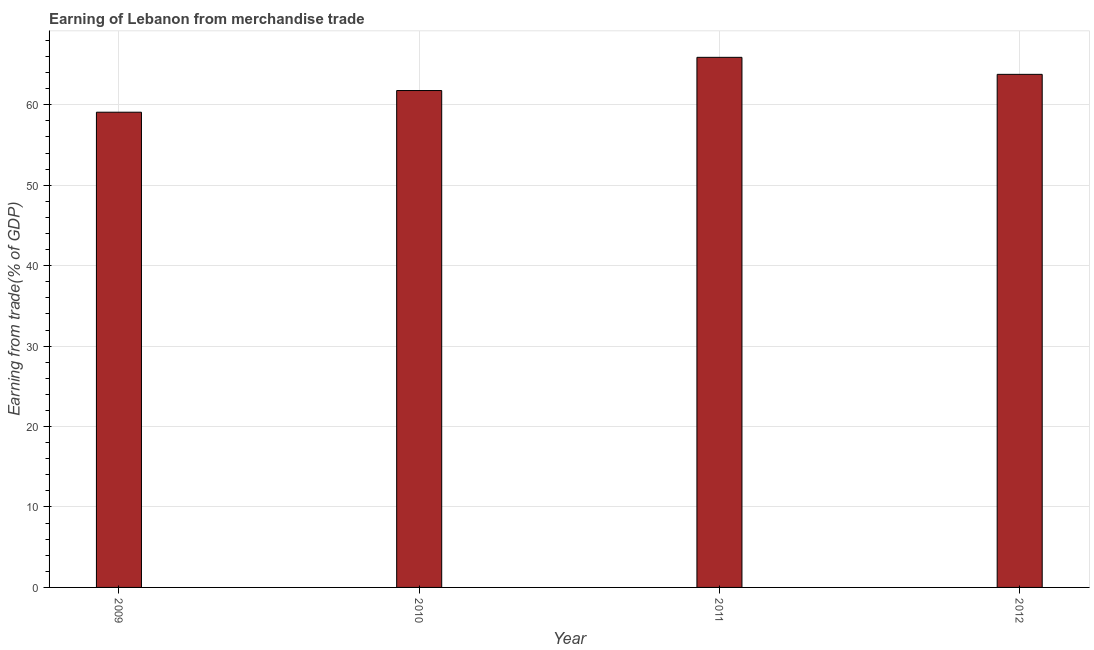Does the graph contain any zero values?
Give a very brief answer. No. What is the title of the graph?
Ensure brevity in your answer.  Earning of Lebanon from merchandise trade. What is the label or title of the Y-axis?
Provide a succinct answer. Earning from trade(% of GDP). What is the earning from merchandise trade in 2012?
Your answer should be compact. 63.79. Across all years, what is the maximum earning from merchandise trade?
Keep it short and to the point. 65.9. Across all years, what is the minimum earning from merchandise trade?
Provide a succinct answer. 59.08. In which year was the earning from merchandise trade maximum?
Your answer should be compact. 2011. What is the sum of the earning from merchandise trade?
Provide a short and direct response. 250.55. What is the difference between the earning from merchandise trade in 2009 and 2012?
Make the answer very short. -4.71. What is the average earning from merchandise trade per year?
Offer a terse response. 62.64. What is the median earning from merchandise trade?
Your answer should be very brief. 62.78. In how many years, is the earning from merchandise trade greater than 14 %?
Offer a very short reply. 4. What is the ratio of the earning from merchandise trade in 2009 to that in 2010?
Give a very brief answer. 0.96. Is the difference between the earning from merchandise trade in 2010 and 2012 greater than the difference between any two years?
Offer a very short reply. No. What is the difference between the highest and the second highest earning from merchandise trade?
Make the answer very short. 2.12. Is the sum of the earning from merchandise trade in 2010 and 2011 greater than the maximum earning from merchandise trade across all years?
Your response must be concise. Yes. What is the difference between the highest and the lowest earning from merchandise trade?
Your response must be concise. 6.82. In how many years, is the earning from merchandise trade greater than the average earning from merchandise trade taken over all years?
Provide a succinct answer. 2. How many bars are there?
Provide a succinct answer. 4. Are all the bars in the graph horizontal?
Make the answer very short. No. How many years are there in the graph?
Ensure brevity in your answer.  4. Are the values on the major ticks of Y-axis written in scientific E-notation?
Offer a terse response. No. What is the Earning from trade(% of GDP) in 2009?
Provide a succinct answer. 59.08. What is the Earning from trade(% of GDP) of 2010?
Your answer should be compact. 61.78. What is the Earning from trade(% of GDP) of 2011?
Give a very brief answer. 65.9. What is the Earning from trade(% of GDP) of 2012?
Offer a terse response. 63.79. What is the difference between the Earning from trade(% of GDP) in 2009 and 2010?
Keep it short and to the point. -2.69. What is the difference between the Earning from trade(% of GDP) in 2009 and 2011?
Your answer should be very brief. -6.82. What is the difference between the Earning from trade(% of GDP) in 2009 and 2012?
Ensure brevity in your answer.  -4.71. What is the difference between the Earning from trade(% of GDP) in 2010 and 2011?
Keep it short and to the point. -4.13. What is the difference between the Earning from trade(% of GDP) in 2010 and 2012?
Ensure brevity in your answer.  -2.01. What is the difference between the Earning from trade(% of GDP) in 2011 and 2012?
Provide a succinct answer. 2.12. What is the ratio of the Earning from trade(% of GDP) in 2009 to that in 2010?
Offer a terse response. 0.96. What is the ratio of the Earning from trade(% of GDP) in 2009 to that in 2011?
Your answer should be very brief. 0.9. What is the ratio of the Earning from trade(% of GDP) in 2009 to that in 2012?
Offer a terse response. 0.93. What is the ratio of the Earning from trade(% of GDP) in 2010 to that in 2011?
Your answer should be compact. 0.94. What is the ratio of the Earning from trade(% of GDP) in 2010 to that in 2012?
Offer a very short reply. 0.97. What is the ratio of the Earning from trade(% of GDP) in 2011 to that in 2012?
Your answer should be very brief. 1.03. 